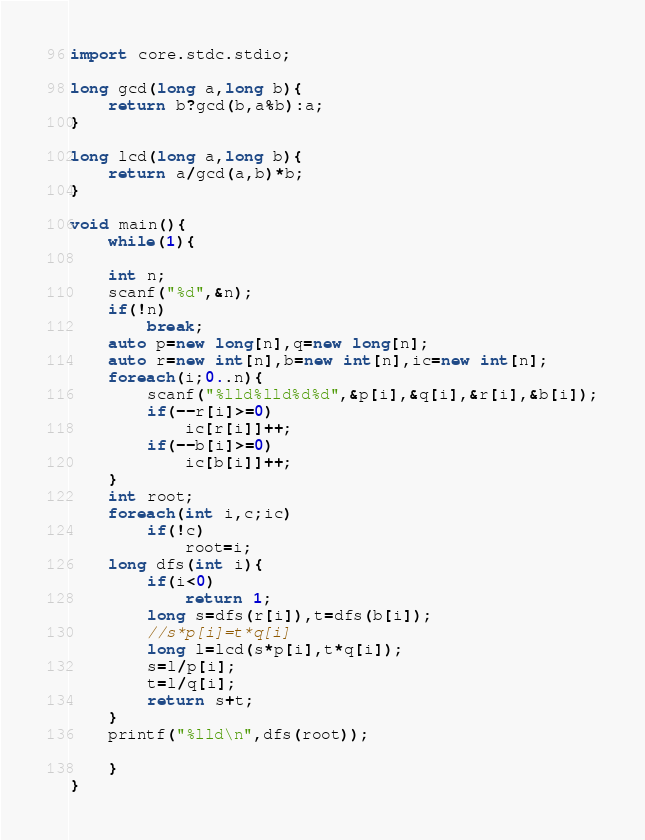<code> <loc_0><loc_0><loc_500><loc_500><_D_>import core.stdc.stdio;

long gcd(long a,long b){
	return b?gcd(b,a%b):a;
}

long lcd(long a,long b){
	return a/gcd(a,b)*b;
}

void main(){
	while(1){
	
	int n;
	scanf("%d",&n);
	if(!n)
		break;
	auto p=new long[n],q=new long[n];
	auto r=new int[n],b=new int[n],ic=new int[n];
	foreach(i;0..n){
		scanf("%lld%lld%d%d",&p[i],&q[i],&r[i],&b[i]);
		if(--r[i]>=0)
			ic[r[i]]++;
		if(--b[i]>=0)
			ic[b[i]]++;
	}
	int root;
	foreach(int i,c;ic)
		if(!c)
			root=i;
	long dfs(int i){
		if(i<0)
			return 1;
		long s=dfs(r[i]),t=dfs(b[i]);
		//s*p[i]=t*q[i]
		long l=lcd(s*p[i],t*q[i]);
		s=l/p[i];
		t=l/q[i];
		return s+t;
	}
	printf("%lld\n",dfs(root));
	
	}
}</code> 